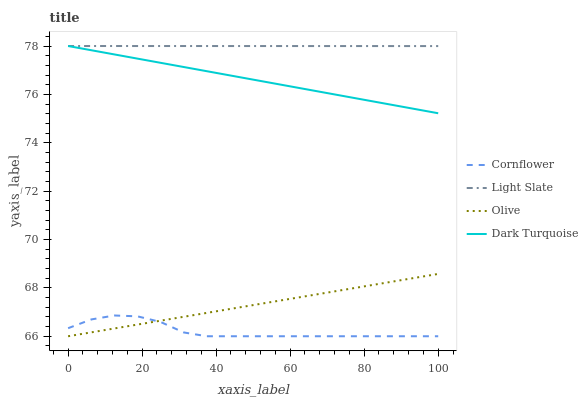Does Cornflower have the minimum area under the curve?
Answer yes or no. Yes. Does Light Slate have the maximum area under the curve?
Answer yes or no. Yes. Does Dark Turquoise have the minimum area under the curve?
Answer yes or no. No. Does Dark Turquoise have the maximum area under the curve?
Answer yes or no. No. Is Dark Turquoise the smoothest?
Answer yes or no. Yes. Is Cornflower the roughest?
Answer yes or no. Yes. Is Cornflower the smoothest?
Answer yes or no. No. Is Dark Turquoise the roughest?
Answer yes or no. No. Does Cornflower have the lowest value?
Answer yes or no. Yes. Does Dark Turquoise have the lowest value?
Answer yes or no. No. Does Dark Turquoise have the highest value?
Answer yes or no. Yes. Does Cornflower have the highest value?
Answer yes or no. No. Is Olive less than Dark Turquoise?
Answer yes or no. Yes. Is Light Slate greater than Olive?
Answer yes or no. Yes. Does Light Slate intersect Dark Turquoise?
Answer yes or no. Yes. Is Light Slate less than Dark Turquoise?
Answer yes or no. No. Is Light Slate greater than Dark Turquoise?
Answer yes or no. No. Does Olive intersect Dark Turquoise?
Answer yes or no. No. 